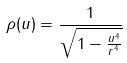Convert formula to latex. <formula><loc_0><loc_0><loc_500><loc_500>\rho ( u ) = \frac { 1 } { \sqrt { 1 - \frac { u ^ { 4 } } { r ^ { 4 } } } }</formula> 